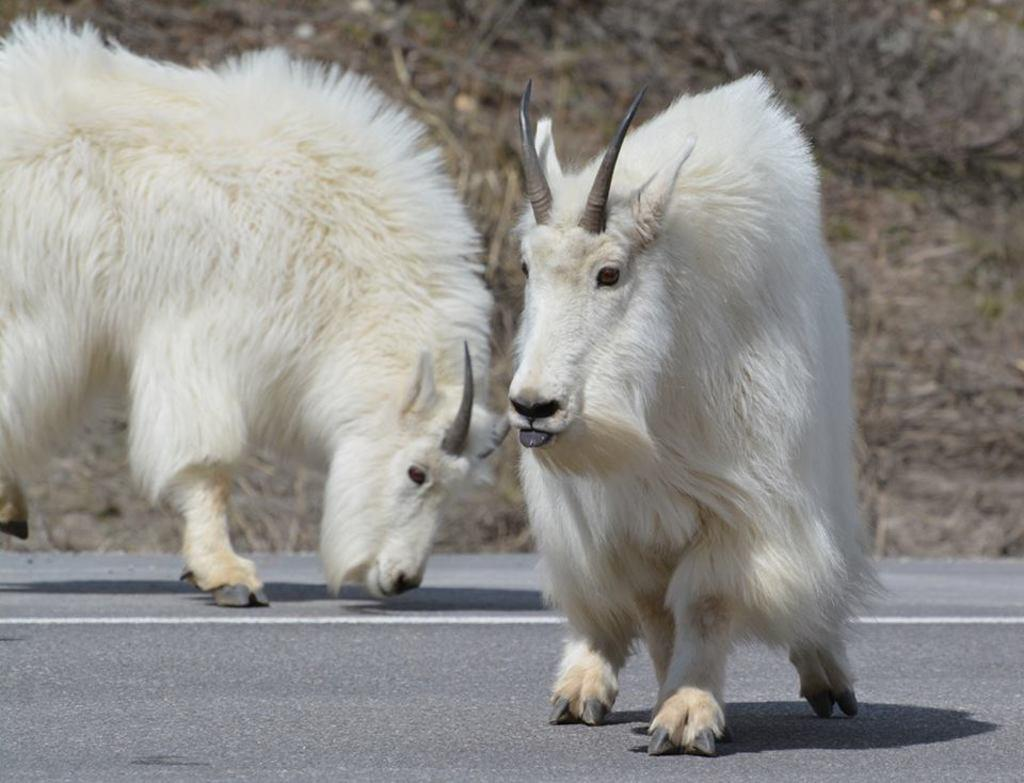What is happening on the road in the image? There are two animals on the road in the image. What type of vegetation can be seen in the image? There are bushes visible in the image. What is the surface of the road made of? There is grass on the surface in the image. What type of light is being used to illuminate the gold in the image? There is no light or gold present in the image; it features two animals on the road and vegetation. How do the animals say good-bye to each other in the image? There is no indication of the animals communicating or saying good-bye in the image. 